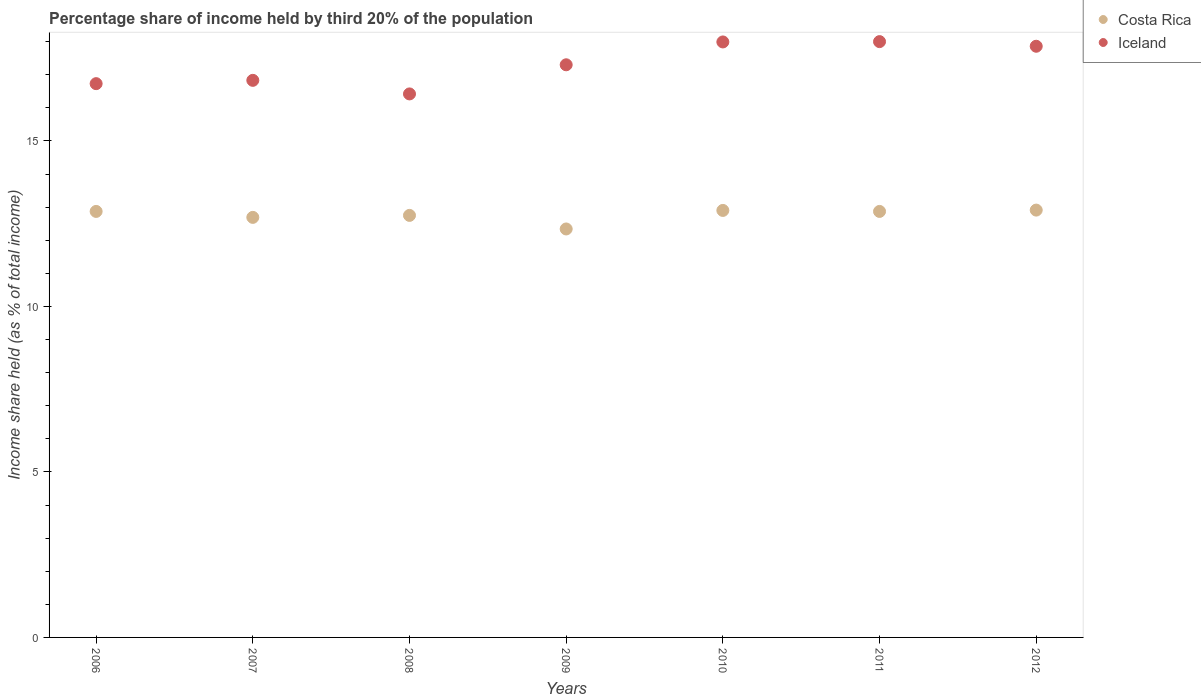Is the number of dotlines equal to the number of legend labels?
Offer a terse response. Yes. Across all years, what is the maximum share of income held by third 20% of the population in Costa Rica?
Provide a succinct answer. 12.91. Across all years, what is the minimum share of income held by third 20% of the population in Costa Rica?
Ensure brevity in your answer.  12.34. In which year was the share of income held by third 20% of the population in Costa Rica maximum?
Give a very brief answer. 2012. What is the total share of income held by third 20% of the population in Costa Rica in the graph?
Make the answer very short. 89.33. What is the difference between the share of income held by third 20% of the population in Iceland in 2006 and that in 2008?
Give a very brief answer. 0.31. What is the difference between the share of income held by third 20% of the population in Iceland in 2007 and the share of income held by third 20% of the population in Costa Rica in 2008?
Your answer should be compact. 4.08. What is the average share of income held by third 20% of the population in Costa Rica per year?
Provide a short and direct response. 12.76. In the year 2008, what is the difference between the share of income held by third 20% of the population in Costa Rica and share of income held by third 20% of the population in Iceland?
Keep it short and to the point. -3.67. What is the ratio of the share of income held by third 20% of the population in Costa Rica in 2008 to that in 2012?
Your response must be concise. 0.99. Is the share of income held by third 20% of the population in Iceland in 2009 less than that in 2012?
Your answer should be compact. Yes. Is the difference between the share of income held by third 20% of the population in Costa Rica in 2011 and 2012 greater than the difference between the share of income held by third 20% of the population in Iceland in 2011 and 2012?
Your answer should be compact. No. What is the difference between the highest and the second highest share of income held by third 20% of the population in Iceland?
Your response must be concise. 0.01. What is the difference between the highest and the lowest share of income held by third 20% of the population in Costa Rica?
Provide a short and direct response. 0.57. In how many years, is the share of income held by third 20% of the population in Costa Rica greater than the average share of income held by third 20% of the population in Costa Rica taken over all years?
Offer a terse response. 4. Does the share of income held by third 20% of the population in Costa Rica monotonically increase over the years?
Your response must be concise. No. Is the share of income held by third 20% of the population in Costa Rica strictly greater than the share of income held by third 20% of the population in Iceland over the years?
Make the answer very short. No. Is the share of income held by third 20% of the population in Iceland strictly less than the share of income held by third 20% of the population in Costa Rica over the years?
Keep it short and to the point. No. What is the difference between two consecutive major ticks on the Y-axis?
Provide a succinct answer. 5. Are the values on the major ticks of Y-axis written in scientific E-notation?
Keep it short and to the point. No. Does the graph contain any zero values?
Give a very brief answer. No. Does the graph contain grids?
Your answer should be very brief. No. What is the title of the graph?
Your answer should be compact. Percentage share of income held by third 20% of the population. Does "Iran" appear as one of the legend labels in the graph?
Offer a very short reply. No. What is the label or title of the Y-axis?
Offer a very short reply. Income share held (as % of total income). What is the Income share held (as % of total income) of Costa Rica in 2006?
Your answer should be very brief. 12.87. What is the Income share held (as % of total income) of Iceland in 2006?
Make the answer very short. 16.73. What is the Income share held (as % of total income) of Costa Rica in 2007?
Offer a terse response. 12.69. What is the Income share held (as % of total income) in Iceland in 2007?
Offer a terse response. 16.83. What is the Income share held (as % of total income) of Costa Rica in 2008?
Ensure brevity in your answer.  12.75. What is the Income share held (as % of total income) in Iceland in 2008?
Give a very brief answer. 16.42. What is the Income share held (as % of total income) in Costa Rica in 2009?
Make the answer very short. 12.34. What is the Income share held (as % of total income) of Costa Rica in 2010?
Provide a short and direct response. 12.9. What is the Income share held (as % of total income) in Iceland in 2010?
Provide a short and direct response. 17.99. What is the Income share held (as % of total income) of Costa Rica in 2011?
Offer a terse response. 12.87. What is the Income share held (as % of total income) of Costa Rica in 2012?
Offer a very short reply. 12.91. What is the Income share held (as % of total income) of Iceland in 2012?
Your answer should be compact. 17.86. Across all years, what is the maximum Income share held (as % of total income) of Costa Rica?
Your response must be concise. 12.91. Across all years, what is the minimum Income share held (as % of total income) in Costa Rica?
Your answer should be compact. 12.34. Across all years, what is the minimum Income share held (as % of total income) in Iceland?
Offer a terse response. 16.42. What is the total Income share held (as % of total income) in Costa Rica in the graph?
Provide a succinct answer. 89.33. What is the total Income share held (as % of total income) of Iceland in the graph?
Your answer should be compact. 121.13. What is the difference between the Income share held (as % of total income) in Costa Rica in 2006 and that in 2007?
Provide a short and direct response. 0.18. What is the difference between the Income share held (as % of total income) in Costa Rica in 2006 and that in 2008?
Your answer should be very brief. 0.12. What is the difference between the Income share held (as % of total income) in Iceland in 2006 and that in 2008?
Your answer should be very brief. 0.31. What is the difference between the Income share held (as % of total income) in Costa Rica in 2006 and that in 2009?
Provide a succinct answer. 0.53. What is the difference between the Income share held (as % of total income) of Iceland in 2006 and that in 2009?
Ensure brevity in your answer.  -0.57. What is the difference between the Income share held (as % of total income) of Costa Rica in 2006 and that in 2010?
Give a very brief answer. -0.03. What is the difference between the Income share held (as % of total income) in Iceland in 2006 and that in 2010?
Offer a terse response. -1.26. What is the difference between the Income share held (as % of total income) of Iceland in 2006 and that in 2011?
Give a very brief answer. -1.27. What is the difference between the Income share held (as % of total income) of Costa Rica in 2006 and that in 2012?
Offer a terse response. -0.04. What is the difference between the Income share held (as % of total income) in Iceland in 2006 and that in 2012?
Ensure brevity in your answer.  -1.13. What is the difference between the Income share held (as % of total income) of Costa Rica in 2007 and that in 2008?
Keep it short and to the point. -0.06. What is the difference between the Income share held (as % of total income) in Iceland in 2007 and that in 2008?
Your response must be concise. 0.41. What is the difference between the Income share held (as % of total income) in Iceland in 2007 and that in 2009?
Make the answer very short. -0.47. What is the difference between the Income share held (as % of total income) of Costa Rica in 2007 and that in 2010?
Your answer should be very brief. -0.21. What is the difference between the Income share held (as % of total income) in Iceland in 2007 and that in 2010?
Your response must be concise. -1.16. What is the difference between the Income share held (as % of total income) in Costa Rica in 2007 and that in 2011?
Provide a short and direct response. -0.18. What is the difference between the Income share held (as % of total income) of Iceland in 2007 and that in 2011?
Your response must be concise. -1.17. What is the difference between the Income share held (as % of total income) in Costa Rica in 2007 and that in 2012?
Provide a short and direct response. -0.22. What is the difference between the Income share held (as % of total income) of Iceland in 2007 and that in 2012?
Provide a succinct answer. -1.03. What is the difference between the Income share held (as % of total income) in Costa Rica in 2008 and that in 2009?
Offer a very short reply. 0.41. What is the difference between the Income share held (as % of total income) in Iceland in 2008 and that in 2009?
Give a very brief answer. -0.88. What is the difference between the Income share held (as % of total income) of Iceland in 2008 and that in 2010?
Provide a short and direct response. -1.57. What is the difference between the Income share held (as % of total income) in Costa Rica in 2008 and that in 2011?
Your response must be concise. -0.12. What is the difference between the Income share held (as % of total income) of Iceland in 2008 and that in 2011?
Keep it short and to the point. -1.58. What is the difference between the Income share held (as % of total income) in Costa Rica in 2008 and that in 2012?
Ensure brevity in your answer.  -0.16. What is the difference between the Income share held (as % of total income) in Iceland in 2008 and that in 2012?
Provide a succinct answer. -1.44. What is the difference between the Income share held (as % of total income) in Costa Rica in 2009 and that in 2010?
Make the answer very short. -0.56. What is the difference between the Income share held (as % of total income) of Iceland in 2009 and that in 2010?
Your answer should be very brief. -0.69. What is the difference between the Income share held (as % of total income) of Costa Rica in 2009 and that in 2011?
Provide a short and direct response. -0.53. What is the difference between the Income share held (as % of total income) in Costa Rica in 2009 and that in 2012?
Your response must be concise. -0.57. What is the difference between the Income share held (as % of total income) in Iceland in 2009 and that in 2012?
Your answer should be compact. -0.56. What is the difference between the Income share held (as % of total income) in Iceland in 2010 and that in 2011?
Provide a short and direct response. -0.01. What is the difference between the Income share held (as % of total income) of Costa Rica in 2010 and that in 2012?
Your answer should be very brief. -0.01. What is the difference between the Income share held (as % of total income) in Iceland in 2010 and that in 2012?
Offer a very short reply. 0.13. What is the difference between the Income share held (as % of total income) in Costa Rica in 2011 and that in 2012?
Make the answer very short. -0.04. What is the difference between the Income share held (as % of total income) in Iceland in 2011 and that in 2012?
Give a very brief answer. 0.14. What is the difference between the Income share held (as % of total income) of Costa Rica in 2006 and the Income share held (as % of total income) of Iceland in 2007?
Offer a terse response. -3.96. What is the difference between the Income share held (as % of total income) in Costa Rica in 2006 and the Income share held (as % of total income) in Iceland in 2008?
Your answer should be compact. -3.55. What is the difference between the Income share held (as % of total income) of Costa Rica in 2006 and the Income share held (as % of total income) of Iceland in 2009?
Keep it short and to the point. -4.43. What is the difference between the Income share held (as % of total income) in Costa Rica in 2006 and the Income share held (as % of total income) in Iceland in 2010?
Ensure brevity in your answer.  -5.12. What is the difference between the Income share held (as % of total income) in Costa Rica in 2006 and the Income share held (as % of total income) in Iceland in 2011?
Give a very brief answer. -5.13. What is the difference between the Income share held (as % of total income) of Costa Rica in 2006 and the Income share held (as % of total income) of Iceland in 2012?
Make the answer very short. -4.99. What is the difference between the Income share held (as % of total income) of Costa Rica in 2007 and the Income share held (as % of total income) of Iceland in 2008?
Offer a terse response. -3.73. What is the difference between the Income share held (as % of total income) in Costa Rica in 2007 and the Income share held (as % of total income) in Iceland in 2009?
Provide a short and direct response. -4.61. What is the difference between the Income share held (as % of total income) in Costa Rica in 2007 and the Income share held (as % of total income) in Iceland in 2011?
Ensure brevity in your answer.  -5.31. What is the difference between the Income share held (as % of total income) of Costa Rica in 2007 and the Income share held (as % of total income) of Iceland in 2012?
Your answer should be very brief. -5.17. What is the difference between the Income share held (as % of total income) in Costa Rica in 2008 and the Income share held (as % of total income) in Iceland in 2009?
Ensure brevity in your answer.  -4.55. What is the difference between the Income share held (as % of total income) of Costa Rica in 2008 and the Income share held (as % of total income) of Iceland in 2010?
Your answer should be compact. -5.24. What is the difference between the Income share held (as % of total income) in Costa Rica in 2008 and the Income share held (as % of total income) in Iceland in 2011?
Your answer should be compact. -5.25. What is the difference between the Income share held (as % of total income) in Costa Rica in 2008 and the Income share held (as % of total income) in Iceland in 2012?
Keep it short and to the point. -5.11. What is the difference between the Income share held (as % of total income) in Costa Rica in 2009 and the Income share held (as % of total income) in Iceland in 2010?
Provide a succinct answer. -5.65. What is the difference between the Income share held (as % of total income) of Costa Rica in 2009 and the Income share held (as % of total income) of Iceland in 2011?
Provide a succinct answer. -5.66. What is the difference between the Income share held (as % of total income) of Costa Rica in 2009 and the Income share held (as % of total income) of Iceland in 2012?
Your answer should be compact. -5.52. What is the difference between the Income share held (as % of total income) of Costa Rica in 2010 and the Income share held (as % of total income) of Iceland in 2011?
Give a very brief answer. -5.1. What is the difference between the Income share held (as % of total income) in Costa Rica in 2010 and the Income share held (as % of total income) in Iceland in 2012?
Give a very brief answer. -4.96. What is the difference between the Income share held (as % of total income) of Costa Rica in 2011 and the Income share held (as % of total income) of Iceland in 2012?
Give a very brief answer. -4.99. What is the average Income share held (as % of total income) of Costa Rica per year?
Give a very brief answer. 12.76. What is the average Income share held (as % of total income) in Iceland per year?
Offer a very short reply. 17.3. In the year 2006, what is the difference between the Income share held (as % of total income) in Costa Rica and Income share held (as % of total income) in Iceland?
Your answer should be very brief. -3.86. In the year 2007, what is the difference between the Income share held (as % of total income) of Costa Rica and Income share held (as % of total income) of Iceland?
Make the answer very short. -4.14. In the year 2008, what is the difference between the Income share held (as % of total income) of Costa Rica and Income share held (as % of total income) of Iceland?
Your response must be concise. -3.67. In the year 2009, what is the difference between the Income share held (as % of total income) of Costa Rica and Income share held (as % of total income) of Iceland?
Provide a short and direct response. -4.96. In the year 2010, what is the difference between the Income share held (as % of total income) of Costa Rica and Income share held (as % of total income) of Iceland?
Provide a succinct answer. -5.09. In the year 2011, what is the difference between the Income share held (as % of total income) of Costa Rica and Income share held (as % of total income) of Iceland?
Give a very brief answer. -5.13. In the year 2012, what is the difference between the Income share held (as % of total income) of Costa Rica and Income share held (as % of total income) of Iceland?
Make the answer very short. -4.95. What is the ratio of the Income share held (as % of total income) in Costa Rica in 2006 to that in 2007?
Offer a very short reply. 1.01. What is the ratio of the Income share held (as % of total income) of Iceland in 2006 to that in 2007?
Your response must be concise. 0.99. What is the ratio of the Income share held (as % of total income) in Costa Rica in 2006 to that in 2008?
Give a very brief answer. 1.01. What is the ratio of the Income share held (as % of total income) of Iceland in 2006 to that in 2008?
Provide a succinct answer. 1.02. What is the ratio of the Income share held (as % of total income) of Costa Rica in 2006 to that in 2009?
Offer a terse response. 1.04. What is the ratio of the Income share held (as % of total income) in Iceland in 2006 to that in 2009?
Keep it short and to the point. 0.97. What is the ratio of the Income share held (as % of total income) in Costa Rica in 2006 to that in 2011?
Offer a very short reply. 1. What is the ratio of the Income share held (as % of total income) of Iceland in 2006 to that in 2011?
Provide a succinct answer. 0.93. What is the ratio of the Income share held (as % of total income) in Costa Rica in 2006 to that in 2012?
Offer a terse response. 1. What is the ratio of the Income share held (as % of total income) in Iceland in 2006 to that in 2012?
Your response must be concise. 0.94. What is the ratio of the Income share held (as % of total income) of Costa Rica in 2007 to that in 2009?
Provide a succinct answer. 1.03. What is the ratio of the Income share held (as % of total income) in Iceland in 2007 to that in 2009?
Offer a terse response. 0.97. What is the ratio of the Income share held (as % of total income) of Costa Rica in 2007 to that in 2010?
Give a very brief answer. 0.98. What is the ratio of the Income share held (as % of total income) in Iceland in 2007 to that in 2010?
Your answer should be compact. 0.94. What is the ratio of the Income share held (as % of total income) of Iceland in 2007 to that in 2011?
Offer a terse response. 0.94. What is the ratio of the Income share held (as % of total income) of Costa Rica in 2007 to that in 2012?
Your response must be concise. 0.98. What is the ratio of the Income share held (as % of total income) in Iceland in 2007 to that in 2012?
Your response must be concise. 0.94. What is the ratio of the Income share held (as % of total income) in Costa Rica in 2008 to that in 2009?
Your answer should be very brief. 1.03. What is the ratio of the Income share held (as % of total income) in Iceland in 2008 to that in 2009?
Make the answer very short. 0.95. What is the ratio of the Income share held (as % of total income) of Costa Rica in 2008 to that in 2010?
Give a very brief answer. 0.99. What is the ratio of the Income share held (as % of total income) of Iceland in 2008 to that in 2010?
Provide a succinct answer. 0.91. What is the ratio of the Income share held (as % of total income) of Iceland in 2008 to that in 2011?
Your answer should be very brief. 0.91. What is the ratio of the Income share held (as % of total income) in Costa Rica in 2008 to that in 2012?
Keep it short and to the point. 0.99. What is the ratio of the Income share held (as % of total income) in Iceland in 2008 to that in 2012?
Provide a short and direct response. 0.92. What is the ratio of the Income share held (as % of total income) of Costa Rica in 2009 to that in 2010?
Provide a short and direct response. 0.96. What is the ratio of the Income share held (as % of total income) in Iceland in 2009 to that in 2010?
Your answer should be compact. 0.96. What is the ratio of the Income share held (as % of total income) in Costa Rica in 2009 to that in 2011?
Your response must be concise. 0.96. What is the ratio of the Income share held (as % of total income) of Iceland in 2009 to that in 2011?
Give a very brief answer. 0.96. What is the ratio of the Income share held (as % of total income) in Costa Rica in 2009 to that in 2012?
Keep it short and to the point. 0.96. What is the ratio of the Income share held (as % of total income) of Iceland in 2009 to that in 2012?
Your response must be concise. 0.97. What is the ratio of the Income share held (as % of total income) in Costa Rica in 2010 to that in 2011?
Provide a short and direct response. 1. What is the ratio of the Income share held (as % of total income) of Iceland in 2010 to that in 2011?
Your response must be concise. 1. What is the ratio of the Income share held (as % of total income) of Iceland in 2010 to that in 2012?
Provide a short and direct response. 1.01. What is the ratio of the Income share held (as % of total income) of Costa Rica in 2011 to that in 2012?
Your answer should be compact. 1. What is the difference between the highest and the second highest Income share held (as % of total income) of Iceland?
Provide a short and direct response. 0.01. What is the difference between the highest and the lowest Income share held (as % of total income) in Costa Rica?
Your answer should be very brief. 0.57. What is the difference between the highest and the lowest Income share held (as % of total income) in Iceland?
Your response must be concise. 1.58. 